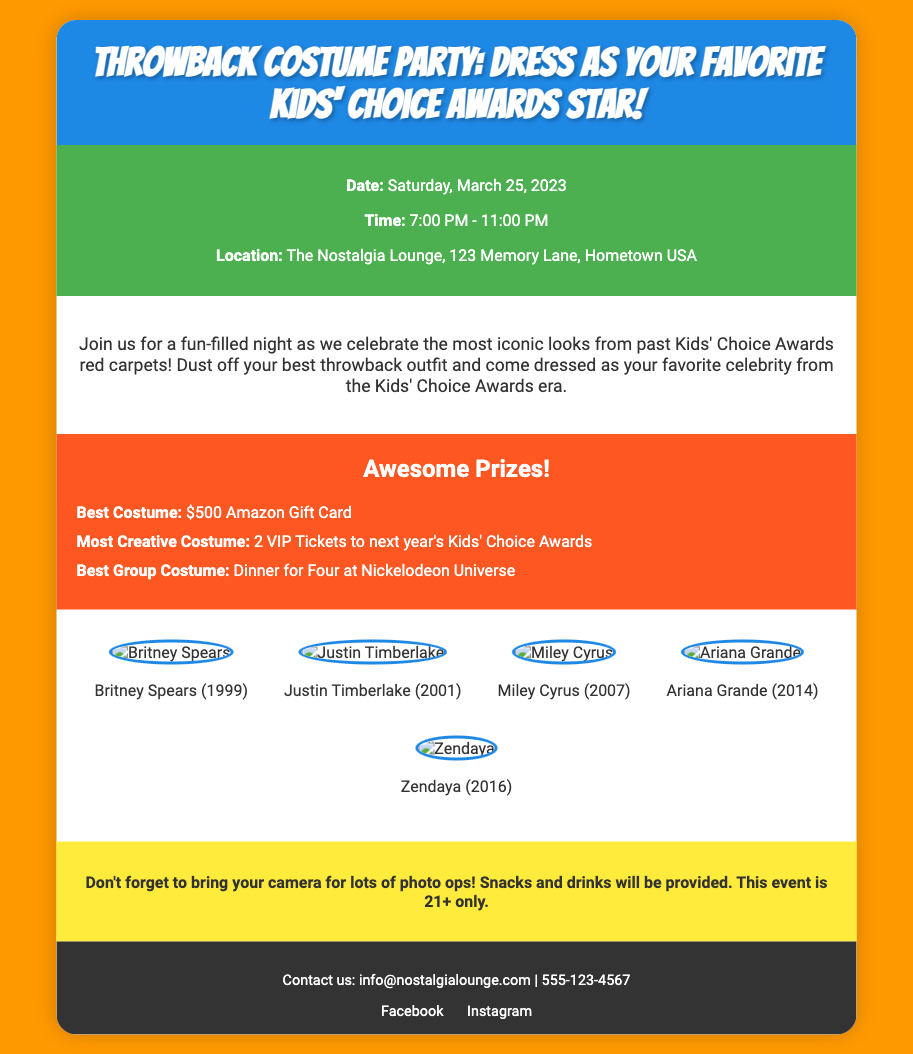What is the date of the event? The date of the event is specified in the event-details section of the document.
Answer: Saturday, March 25, 2023 What time does the event start? The time is listed in the event-details section, outlining when the event begins.
Answer: 7:00 PM Where is the event taking place? The location is mentioned in the event-details section of the document, indicating the venue for the party.
Answer: The Nostalgia Lounge, 123 Memory Lane, Hometown USA What is the prize for Best Costume? This information is found in the prizes section, detailing the awards available for participants.
Answer: $500 Amazon Gift Card Who is featured in the throwback images? The celebrities highlighted include images from past Kids' Choice Awards, with names and years shown beneath each picture.
Answer: Britney Spears, Justin Timberlake, Miley Cyrus, Ariana Grande, Zendaya What is the age restriction for the event? The note section at the bottom of the document mentions the age requirement for attendees of the event.
Answer: 21+ only What kind of snacks will be provided? The description mentions that snacks and drinks will be available, but doesn't specify the types.
Answer: Snacks and drinks What is the prize for Most Creative Costume? The prizes section lists specific awards and their corresponding reward for creative costumes.
Answer: 2 VIP Tickets to next year's Kids' Choice Awards When will the event end? The ending time is indicated in the event-details section, stating the duration of the party.
Answer: 11:00 PM 